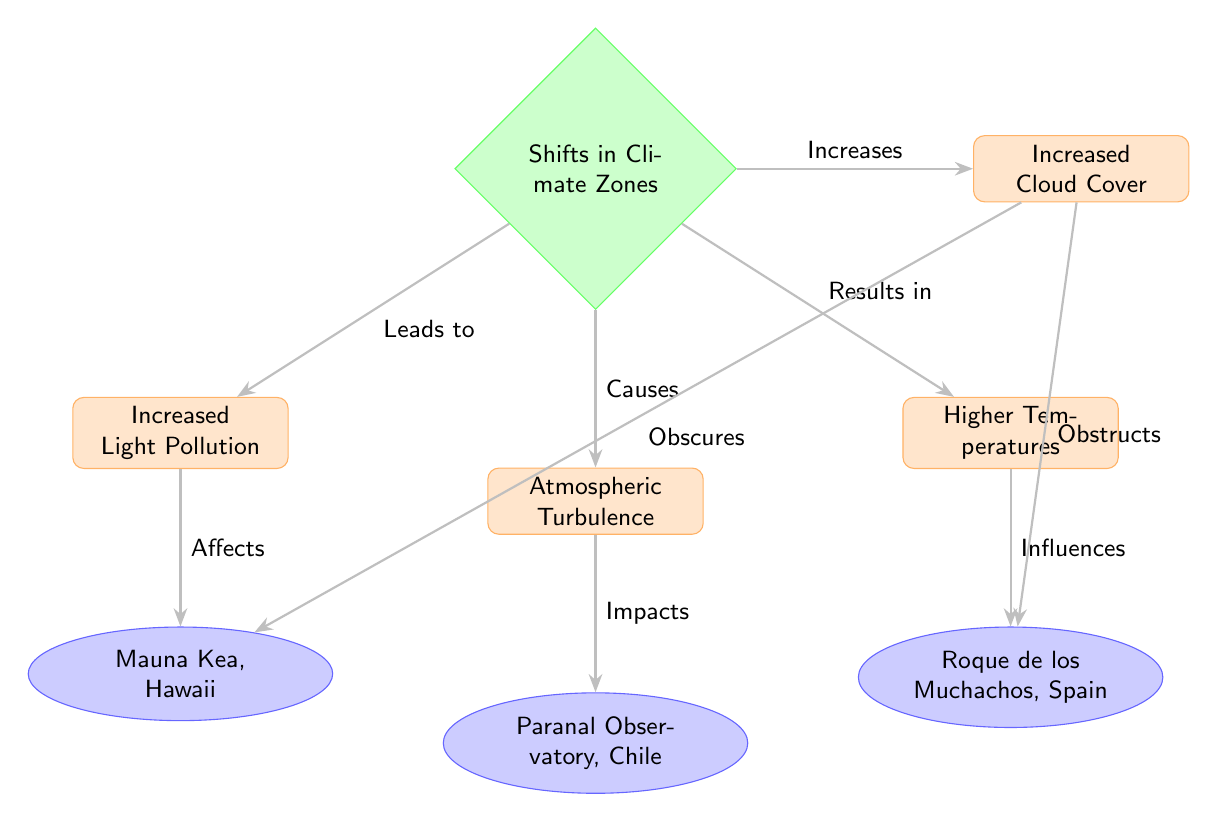What are the effects of shifts in climate zones? The diagram lists four effects stemming from shifts in climate zones: increased light pollution, atmospheric turbulence, higher temperatures, and increased cloud cover.
Answer: Increased light pollution, atmospheric turbulence, higher temperatures, increased cloud cover How many locations are mentioned in the diagram? There are three locations mentioned in the diagram: Mauna Kea, Paranal Observatory, and Roque de los Muchachos.
Answer: 3 Which location is affected by increased light pollution? The diagram shows an arrow from increased light pollution to Mauna Kea, indicating that it is affected by this issue.
Answer: Mauna Kea What influence does higher temperatures have on observatories? The diagram specifies that higher temperatures influence Roque de los Muchachos, suggesting it is negatively impacted by rising temperatures.
Answer: Roque de los Muchachos What does increased cloud cover do to Mauna Kea? According to the diagram, increased cloud cover obscures Mauna Kea, indicating that it obstructs visibility for astronomical observations.
Answer: Obscures Which effect results from increased cloud cover? The diagram includes an arrow going to indicate how increased cloud cover obstructs Roque de los Muchachos as a result of higher cloudiness.
Answer: Obstructs What is the relationship between atmospheric turbulence and Paranal Observatory? The diagram demonstrates a direct connection where atmospheric turbulence impacts Paranal Observatory, indicating that this phenomenon detrimentally affects its observations.
Answer: Impacts Which causes lead to atmospheric turbulence? The diagram implies that shifts in climate zones are the root cause of atmospheric turbulence, establishing a direct link between them.
Answer: Shifts in Climate Zones 